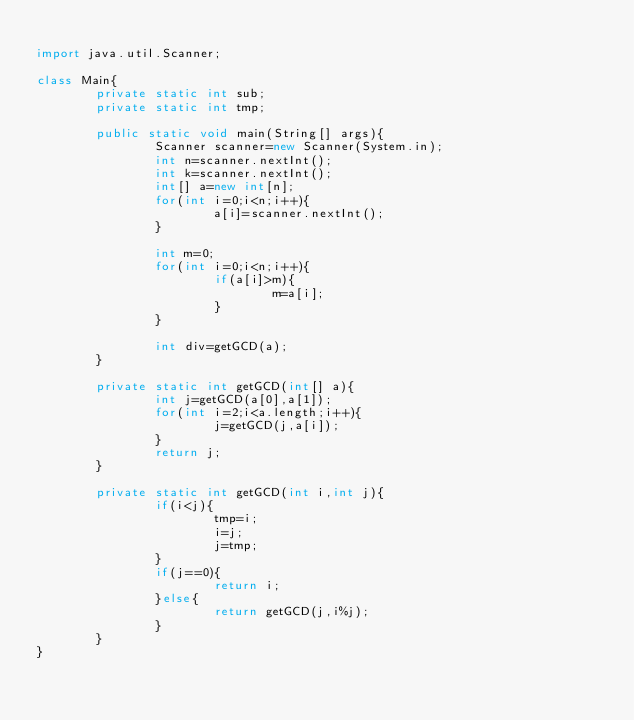Convert code to text. <code><loc_0><loc_0><loc_500><loc_500><_Java_>
import java.util.Scanner;

class Main{
        private static int sub;
        private static int tmp;

        public static void main(String[] args){
                Scanner scanner=new Scanner(System.in);
                int n=scanner.nextInt();
                int k=scanner.nextInt();
                int[] a=new int[n];
                for(int i=0;i<n;i++){
                        a[i]=scanner.nextInt();
                }

                int m=0;
                for(int i=0;i<n;i++){
                        if(a[i]>m){
                                m=a[i];
                        }
                }

                int div=getGCD(a);
        }

        private static int getGCD(int[] a){
                int j=getGCD(a[0],a[1]);
                for(int i=2;i<a.length;i++){
                        j=getGCD(j,a[i]);
                }
                return j;
        }

        private static int getGCD(int i,int j){
                if(i<j){
                        tmp=i;
                        i=j;
                        j=tmp;
                }
                if(j==0){
                        return i;
                }else{
                        return getGCD(j,i%j);
                }
        }
}</code> 